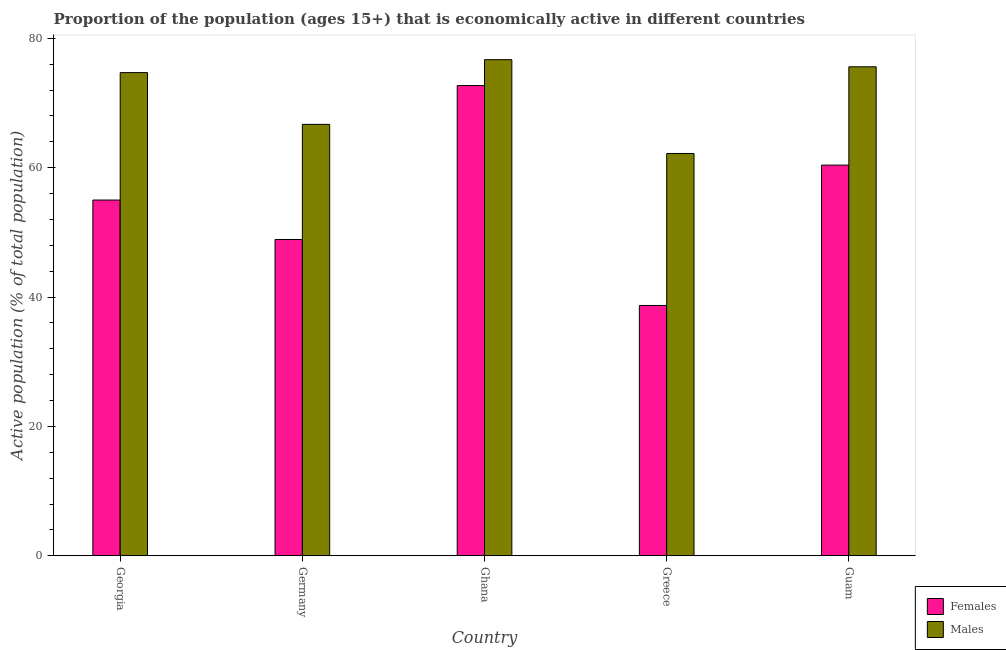How many groups of bars are there?
Make the answer very short. 5. How many bars are there on the 3rd tick from the right?
Keep it short and to the point. 2. In how many cases, is the number of bars for a given country not equal to the number of legend labels?
Keep it short and to the point. 0. What is the percentage of economically active male population in Germany?
Offer a terse response. 66.7. Across all countries, what is the maximum percentage of economically active female population?
Your answer should be very brief. 72.7. Across all countries, what is the minimum percentage of economically active female population?
Keep it short and to the point. 38.7. What is the total percentage of economically active male population in the graph?
Offer a very short reply. 355.9. What is the difference between the percentage of economically active female population in Georgia and that in Germany?
Provide a succinct answer. 6.1. What is the difference between the percentage of economically active female population in Georgia and the percentage of economically active male population in Greece?
Your answer should be very brief. -7.2. What is the average percentage of economically active female population per country?
Give a very brief answer. 55.14. What is the ratio of the percentage of economically active male population in Georgia to that in Guam?
Keep it short and to the point. 0.99. Is the percentage of economically active female population in Georgia less than that in Greece?
Ensure brevity in your answer.  No. What is the difference between the highest and the second highest percentage of economically active female population?
Offer a terse response. 12.3. What is the difference between the highest and the lowest percentage of economically active male population?
Give a very brief answer. 14.5. What does the 2nd bar from the left in Greece represents?
Give a very brief answer. Males. What does the 1st bar from the right in Germany represents?
Your answer should be compact. Males. Are all the bars in the graph horizontal?
Provide a succinct answer. No. How many countries are there in the graph?
Offer a terse response. 5. What is the difference between two consecutive major ticks on the Y-axis?
Your answer should be compact. 20. Are the values on the major ticks of Y-axis written in scientific E-notation?
Your answer should be compact. No. Does the graph contain any zero values?
Make the answer very short. No. How are the legend labels stacked?
Your answer should be very brief. Vertical. What is the title of the graph?
Offer a very short reply. Proportion of the population (ages 15+) that is economically active in different countries. Does "Boys" appear as one of the legend labels in the graph?
Your response must be concise. No. What is the label or title of the Y-axis?
Your answer should be very brief. Active population (% of total population). What is the Active population (% of total population) of Females in Georgia?
Offer a terse response. 55. What is the Active population (% of total population) of Males in Georgia?
Offer a terse response. 74.7. What is the Active population (% of total population) of Females in Germany?
Your answer should be very brief. 48.9. What is the Active population (% of total population) of Males in Germany?
Give a very brief answer. 66.7. What is the Active population (% of total population) in Females in Ghana?
Provide a succinct answer. 72.7. What is the Active population (% of total population) of Males in Ghana?
Your response must be concise. 76.7. What is the Active population (% of total population) in Females in Greece?
Provide a short and direct response. 38.7. What is the Active population (% of total population) in Males in Greece?
Your answer should be very brief. 62.2. What is the Active population (% of total population) in Females in Guam?
Provide a short and direct response. 60.4. What is the Active population (% of total population) of Males in Guam?
Make the answer very short. 75.6. Across all countries, what is the maximum Active population (% of total population) of Females?
Keep it short and to the point. 72.7. Across all countries, what is the maximum Active population (% of total population) of Males?
Keep it short and to the point. 76.7. Across all countries, what is the minimum Active population (% of total population) in Females?
Give a very brief answer. 38.7. Across all countries, what is the minimum Active population (% of total population) in Males?
Give a very brief answer. 62.2. What is the total Active population (% of total population) of Females in the graph?
Provide a short and direct response. 275.7. What is the total Active population (% of total population) of Males in the graph?
Ensure brevity in your answer.  355.9. What is the difference between the Active population (% of total population) of Females in Georgia and that in Germany?
Give a very brief answer. 6.1. What is the difference between the Active population (% of total population) of Males in Georgia and that in Germany?
Your answer should be compact. 8. What is the difference between the Active population (% of total population) of Females in Georgia and that in Ghana?
Keep it short and to the point. -17.7. What is the difference between the Active population (% of total population) of Females in Georgia and that in Guam?
Ensure brevity in your answer.  -5.4. What is the difference between the Active population (% of total population) of Females in Germany and that in Ghana?
Offer a very short reply. -23.8. What is the difference between the Active population (% of total population) in Males in Germany and that in Ghana?
Your answer should be compact. -10. What is the difference between the Active population (% of total population) of Females in Germany and that in Greece?
Your answer should be very brief. 10.2. What is the difference between the Active population (% of total population) of Females in Germany and that in Guam?
Your response must be concise. -11.5. What is the difference between the Active population (% of total population) in Females in Ghana and that in Greece?
Give a very brief answer. 34. What is the difference between the Active population (% of total population) in Males in Ghana and that in Greece?
Ensure brevity in your answer.  14.5. What is the difference between the Active population (% of total population) in Females in Greece and that in Guam?
Ensure brevity in your answer.  -21.7. What is the difference between the Active population (% of total population) of Females in Georgia and the Active population (% of total population) of Males in Ghana?
Make the answer very short. -21.7. What is the difference between the Active population (% of total population) of Females in Georgia and the Active population (% of total population) of Males in Greece?
Offer a very short reply. -7.2. What is the difference between the Active population (% of total population) of Females in Georgia and the Active population (% of total population) of Males in Guam?
Provide a succinct answer. -20.6. What is the difference between the Active population (% of total population) in Females in Germany and the Active population (% of total population) in Males in Ghana?
Keep it short and to the point. -27.8. What is the difference between the Active population (% of total population) in Females in Germany and the Active population (% of total population) in Males in Guam?
Your answer should be compact. -26.7. What is the difference between the Active population (% of total population) in Females in Ghana and the Active population (% of total population) in Males in Greece?
Your response must be concise. 10.5. What is the difference between the Active population (% of total population) of Females in Greece and the Active population (% of total population) of Males in Guam?
Offer a very short reply. -36.9. What is the average Active population (% of total population) in Females per country?
Provide a succinct answer. 55.14. What is the average Active population (% of total population) in Males per country?
Offer a terse response. 71.18. What is the difference between the Active population (% of total population) in Females and Active population (% of total population) in Males in Georgia?
Ensure brevity in your answer.  -19.7. What is the difference between the Active population (% of total population) of Females and Active population (% of total population) of Males in Germany?
Offer a terse response. -17.8. What is the difference between the Active population (% of total population) of Females and Active population (% of total population) of Males in Greece?
Offer a terse response. -23.5. What is the difference between the Active population (% of total population) of Females and Active population (% of total population) of Males in Guam?
Make the answer very short. -15.2. What is the ratio of the Active population (% of total population) of Females in Georgia to that in Germany?
Give a very brief answer. 1.12. What is the ratio of the Active population (% of total population) of Males in Georgia to that in Germany?
Offer a very short reply. 1.12. What is the ratio of the Active population (% of total population) of Females in Georgia to that in Ghana?
Provide a succinct answer. 0.76. What is the ratio of the Active population (% of total population) of Males in Georgia to that in Ghana?
Your response must be concise. 0.97. What is the ratio of the Active population (% of total population) of Females in Georgia to that in Greece?
Offer a very short reply. 1.42. What is the ratio of the Active population (% of total population) in Males in Georgia to that in Greece?
Your response must be concise. 1.2. What is the ratio of the Active population (% of total population) in Females in Georgia to that in Guam?
Offer a terse response. 0.91. What is the ratio of the Active population (% of total population) in Females in Germany to that in Ghana?
Provide a succinct answer. 0.67. What is the ratio of the Active population (% of total population) in Males in Germany to that in Ghana?
Give a very brief answer. 0.87. What is the ratio of the Active population (% of total population) of Females in Germany to that in Greece?
Provide a short and direct response. 1.26. What is the ratio of the Active population (% of total population) in Males in Germany to that in Greece?
Your answer should be very brief. 1.07. What is the ratio of the Active population (% of total population) of Females in Germany to that in Guam?
Provide a succinct answer. 0.81. What is the ratio of the Active population (% of total population) of Males in Germany to that in Guam?
Provide a short and direct response. 0.88. What is the ratio of the Active population (% of total population) in Females in Ghana to that in Greece?
Give a very brief answer. 1.88. What is the ratio of the Active population (% of total population) of Males in Ghana to that in Greece?
Offer a very short reply. 1.23. What is the ratio of the Active population (% of total population) of Females in Ghana to that in Guam?
Your answer should be compact. 1.2. What is the ratio of the Active population (% of total population) in Males in Ghana to that in Guam?
Keep it short and to the point. 1.01. What is the ratio of the Active population (% of total population) of Females in Greece to that in Guam?
Give a very brief answer. 0.64. What is the ratio of the Active population (% of total population) of Males in Greece to that in Guam?
Make the answer very short. 0.82. What is the difference between the highest and the second highest Active population (% of total population) of Males?
Make the answer very short. 1.1. What is the difference between the highest and the lowest Active population (% of total population) of Males?
Your answer should be compact. 14.5. 